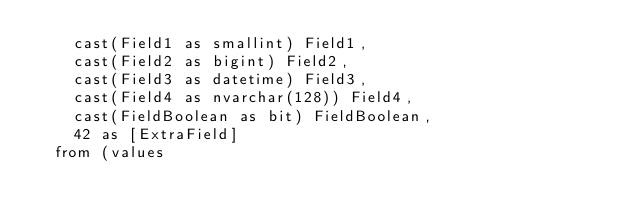<code> <loc_0><loc_0><loc_500><loc_500><_SQL_>		cast(Field1 as smallint) Field1,
		cast(Field2 as bigint) Field2,
		cast(Field3 as datetime) Field3,
		cast(Field4 as nvarchar(128)) Field4,
		cast(FieldBoolean as bit) FieldBoolean,
		42 as [ExtraField]
	from (values</code> 